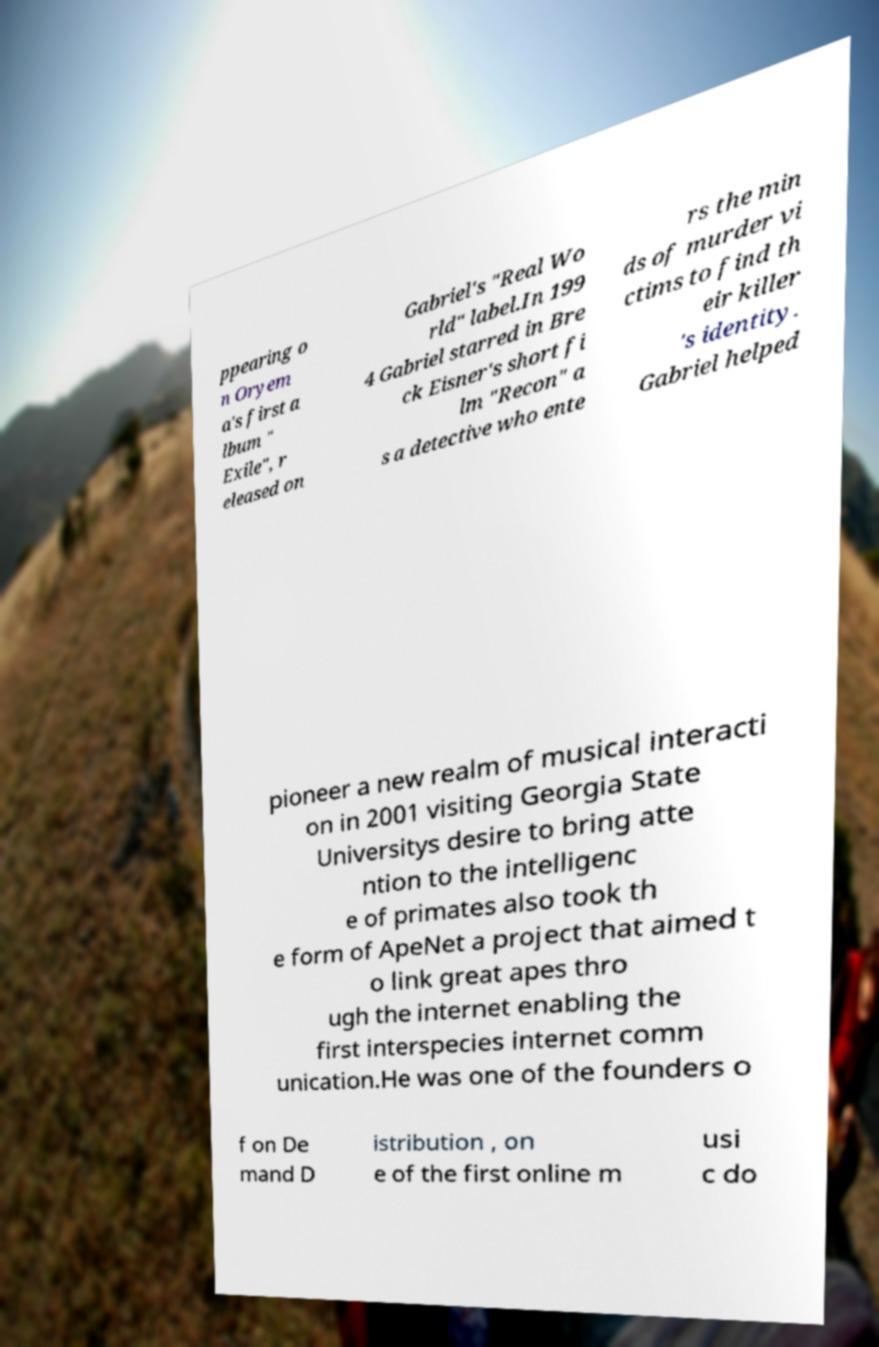I need the written content from this picture converted into text. Can you do that? ppearing o n Oryem a's first a lbum " Exile", r eleased on Gabriel's "Real Wo rld" label.In 199 4 Gabriel starred in Bre ck Eisner's short fi lm "Recon" a s a detective who ente rs the min ds of murder vi ctims to find th eir killer 's identity. Gabriel helped pioneer a new realm of musical interacti on in 2001 visiting Georgia State Universitys desire to bring atte ntion to the intelligenc e of primates also took th e form of ApeNet a project that aimed t o link great apes thro ugh the internet enabling the first interspecies internet comm unication.He was one of the founders o f on De mand D istribution , on e of the first online m usi c do 